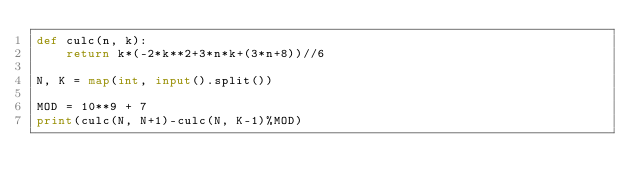<code> <loc_0><loc_0><loc_500><loc_500><_Python_>def culc(n, k):
    return k*(-2*k**2+3*n*k+(3*n+8))//6

N, K = map(int, input().split())

MOD = 10**9 + 7
print(culc(N, N+1)-culc(N, K-1)%MOD)</code> 